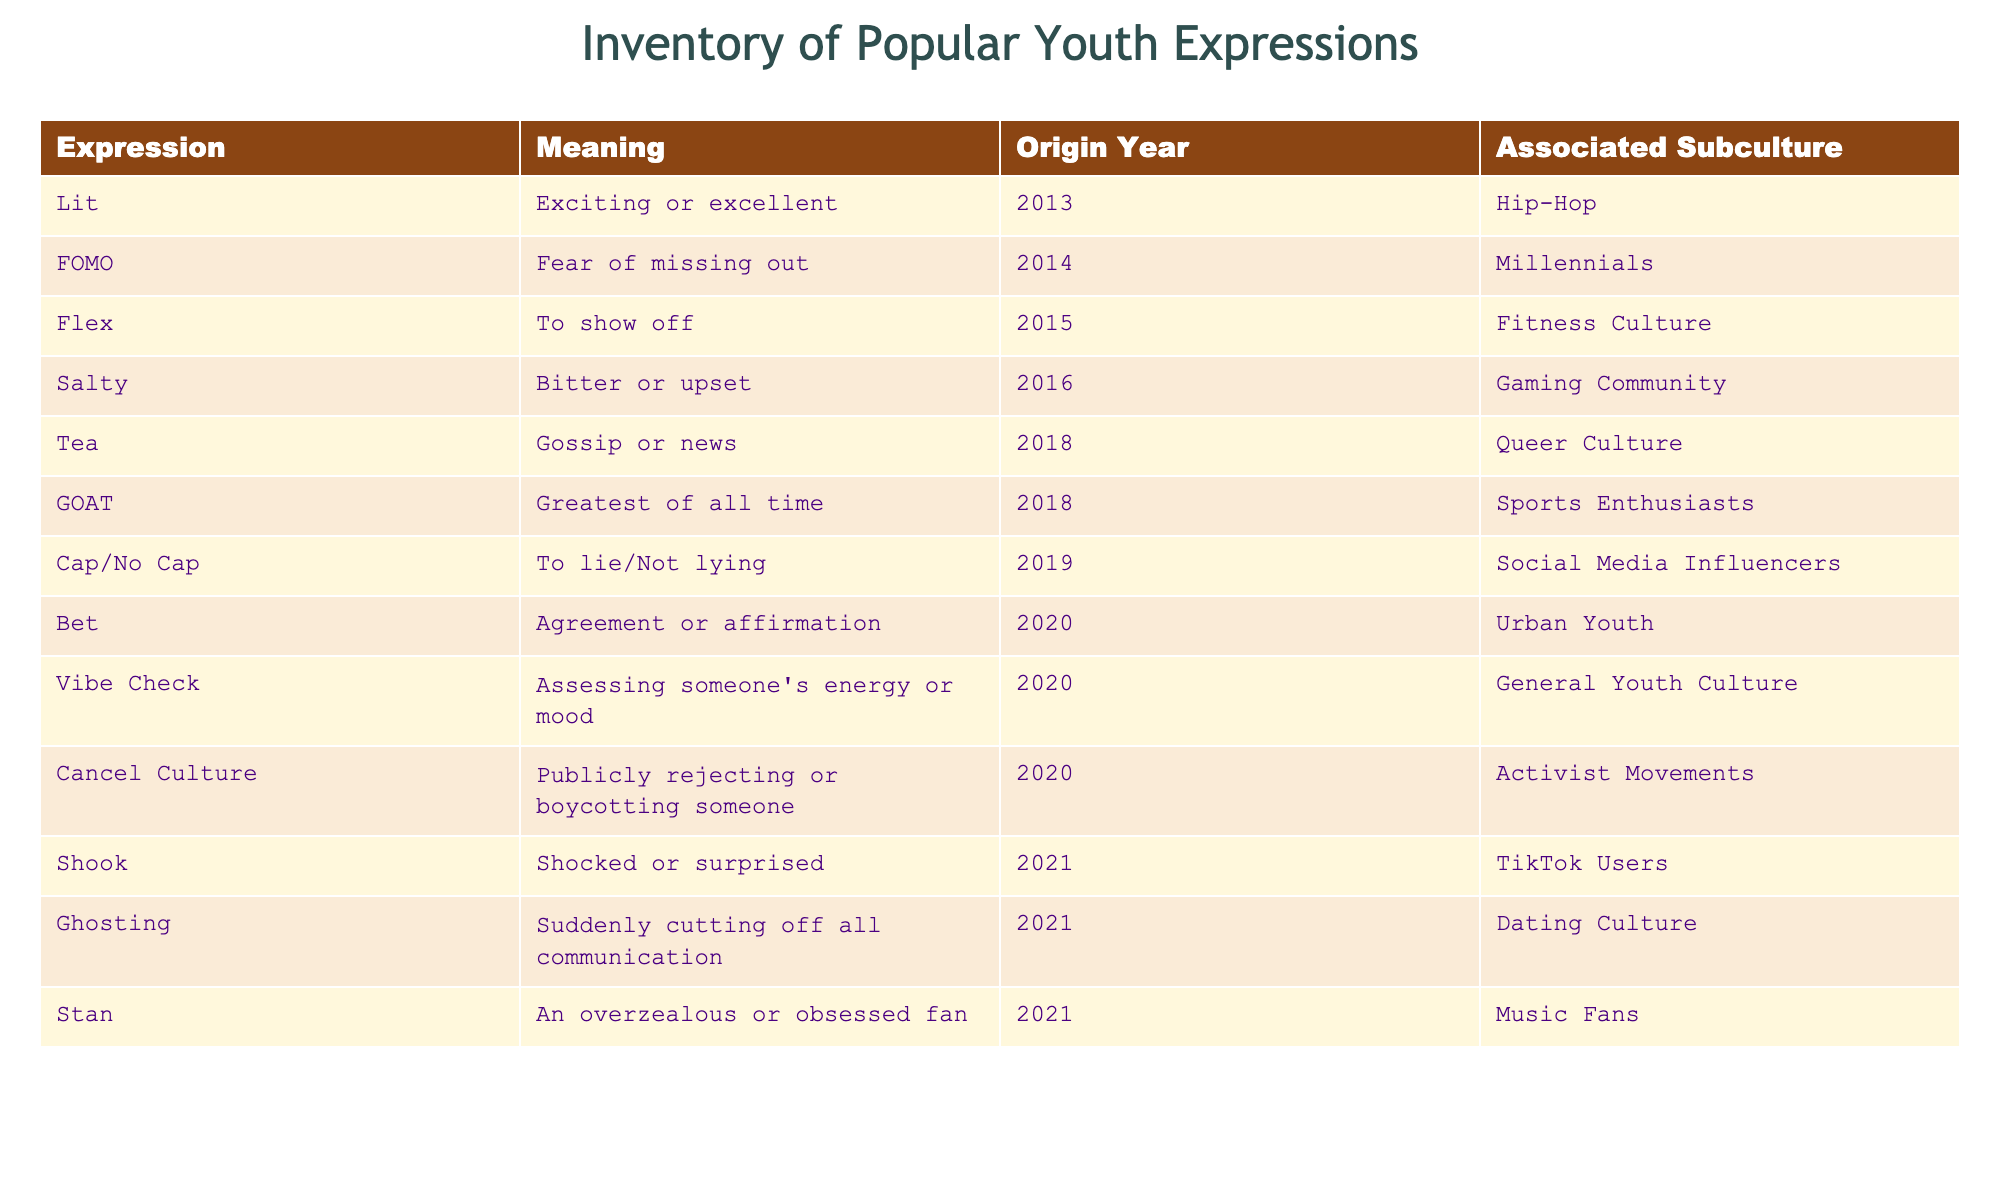What does "FOMO" stand for? "FOMO" stands for "Fear of missing out," as indicated in the table. This information is directly retrievable from the "Meaning" column corresponding to the expression "FOMO."
Answer: Fear of missing out Which expression was associated with the "Gaming Community"? The expression "Salty" is associated with the "Gaming Community," as shown in the table under the "Associated Subculture" column for that entry.
Answer: Salty How many expressions originated in 2020? There are three expressions that originated in 2020: "Bet," "Vibe Check," and "Cancel Culture." To find this, one can scan the "Origin Year" column for entries listed as "2020."
Answer: 3 What is the meaning of the expression "Cap"? The expression "Cap" means "to lie." This can be verified by looking at the "Meaning" column corresponding to "Cap" in the table.
Answer: To lie Which subculture has the expression "Stan"? "Stan" is associated with "Music Fans," as specified in the "Associated Subculture" column next to the entry for "Stan."
Answer: Music Fans Is "Ghosting" associated with TikTok Users? No, "Ghosting" is not associated with TikTok Users; it is instead affiliated with "Dating Culture," as stated in the corresponding entry in the table.
Answer: No What is the average origin year of expressions that began in the years 2018 and later? The expressions that originated in 2018 and later are "Tea" (2018), "GOAT" (2018), "Cap/No Cap" (2019), "Bet" (2020), "Vibe Check" (2020), "Cancel Culture" (2020), "Shook" (2021), "Ghosting" (2021), and "Stan" (2021). The average can be calculated as (2018 + 2018 + 2019 + 2020 + 2020 + 2020 + 2021 + 2021 + 2021) / 9 = 2019.33.
Answer: 2019.33 Which expression was first introduced in 2013? The expression introduced in 2013 is "Lit," as clearly stated in the "Origin Year" column of the table.
Answer: Lit What does "Vibe Check" mean? "Vibe Check" refers to assessing someone's energy or mood, as defined in the "Meaning" column for that expression within the table.
Answer: Assessing someone's energy or mood 